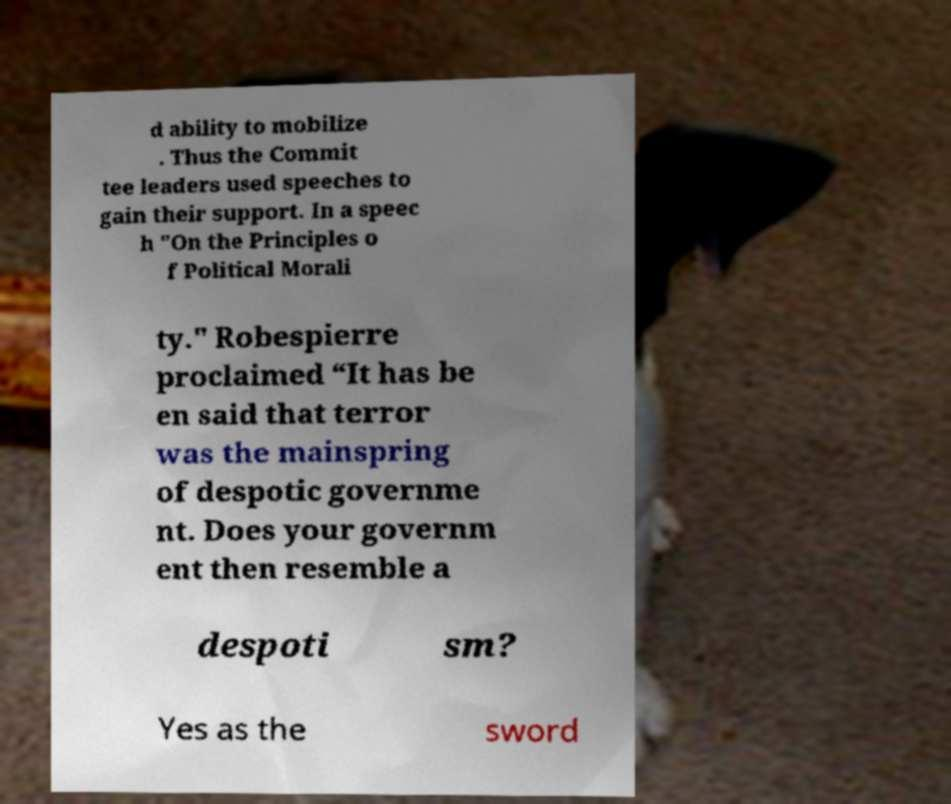Can you read and provide the text displayed in the image?This photo seems to have some interesting text. Can you extract and type it out for me? d ability to mobilize . Thus the Commit tee leaders used speeches to gain their support. In a speec h "On the Principles o f Political Morali ty." Robespierre proclaimed “It has be en said that terror was the mainspring of despotic governme nt. Does your governm ent then resemble a despoti sm? Yes as the sword 